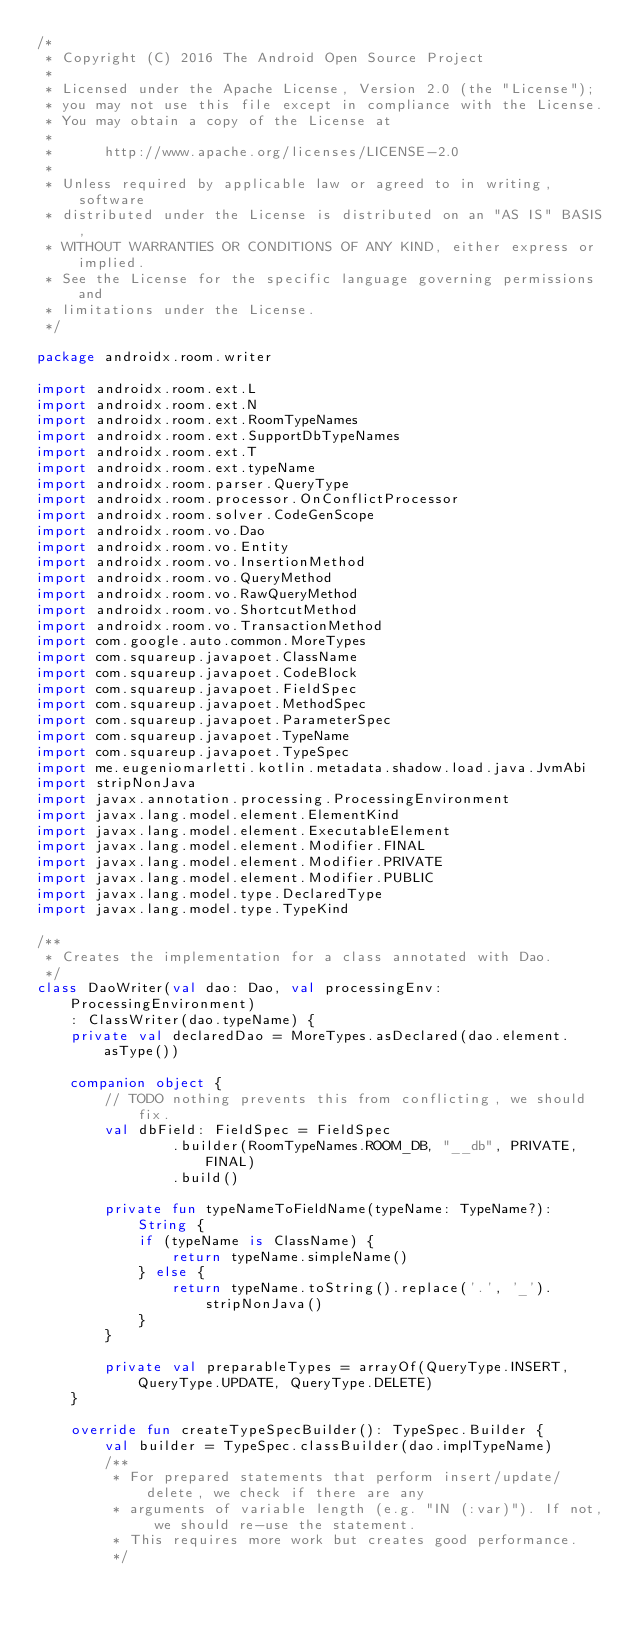<code> <loc_0><loc_0><loc_500><loc_500><_Kotlin_>/*
 * Copyright (C) 2016 The Android Open Source Project
 *
 * Licensed under the Apache License, Version 2.0 (the "License");
 * you may not use this file except in compliance with the License.
 * You may obtain a copy of the License at
 *
 *      http://www.apache.org/licenses/LICENSE-2.0
 *
 * Unless required by applicable law or agreed to in writing, software
 * distributed under the License is distributed on an "AS IS" BASIS,
 * WITHOUT WARRANTIES OR CONDITIONS OF ANY KIND, either express or implied.
 * See the License for the specific language governing permissions and
 * limitations under the License.
 */

package androidx.room.writer

import androidx.room.ext.L
import androidx.room.ext.N
import androidx.room.ext.RoomTypeNames
import androidx.room.ext.SupportDbTypeNames
import androidx.room.ext.T
import androidx.room.ext.typeName
import androidx.room.parser.QueryType
import androidx.room.processor.OnConflictProcessor
import androidx.room.solver.CodeGenScope
import androidx.room.vo.Dao
import androidx.room.vo.Entity
import androidx.room.vo.InsertionMethod
import androidx.room.vo.QueryMethod
import androidx.room.vo.RawQueryMethod
import androidx.room.vo.ShortcutMethod
import androidx.room.vo.TransactionMethod
import com.google.auto.common.MoreTypes
import com.squareup.javapoet.ClassName
import com.squareup.javapoet.CodeBlock
import com.squareup.javapoet.FieldSpec
import com.squareup.javapoet.MethodSpec
import com.squareup.javapoet.ParameterSpec
import com.squareup.javapoet.TypeName
import com.squareup.javapoet.TypeSpec
import me.eugeniomarletti.kotlin.metadata.shadow.load.java.JvmAbi
import stripNonJava
import javax.annotation.processing.ProcessingEnvironment
import javax.lang.model.element.ElementKind
import javax.lang.model.element.ExecutableElement
import javax.lang.model.element.Modifier.FINAL
import javax.lang.model.element.Modifier.PRIVATE
import javax.lang.model.element.Modifier.PUBLIC
import javax.lang.model.type.DeclaredType
import javax.lang.model.type.TypeKind

/**
 * Creates the implementation for a class annotated with Dao.
 */
class DaoWriter(val dao: Dao, val processingEnv: ProcessingEnvironment)
    : ClassWriter(dao.typeName) {
    private val declaredDao = MoreTypes.asDeclared(dao.element.asType())

    companion object {
        // TODO nothing prevents this from conflicting, we should fix.
        val dbField: FieldSpec = FieldSpec
                .builder(RoomTypeNames.ROOM_DB, "__db", PRIVATE, FINAL)
                .build()

        private fun typeNameToFieldName(typeName: TypeName?): String {
            if (typeName is ClassName) {
                return typeName.simpleName()
            } else {
                return typeName.toString().replace('.', '_').stripNonJava()
            }
        }

        private val preparableTypes = arrayOf(QueryType.INSERT, QueryType.UPDATE, QueryType.DELETE)
    }

    override fun createTypeSpecBuilder(): TypeSpec.Builder {
        val builder = TypeSpec.classBuilder(dao.implTypeName)
        /**
         * For prepared statements that perform insert/update/delete, we check if there are any
         * arguments of variable length (e.g. "IN (:var)"). If not, we should re-use the statement.
         * This requires more work but creates good performance.
         */</code> 